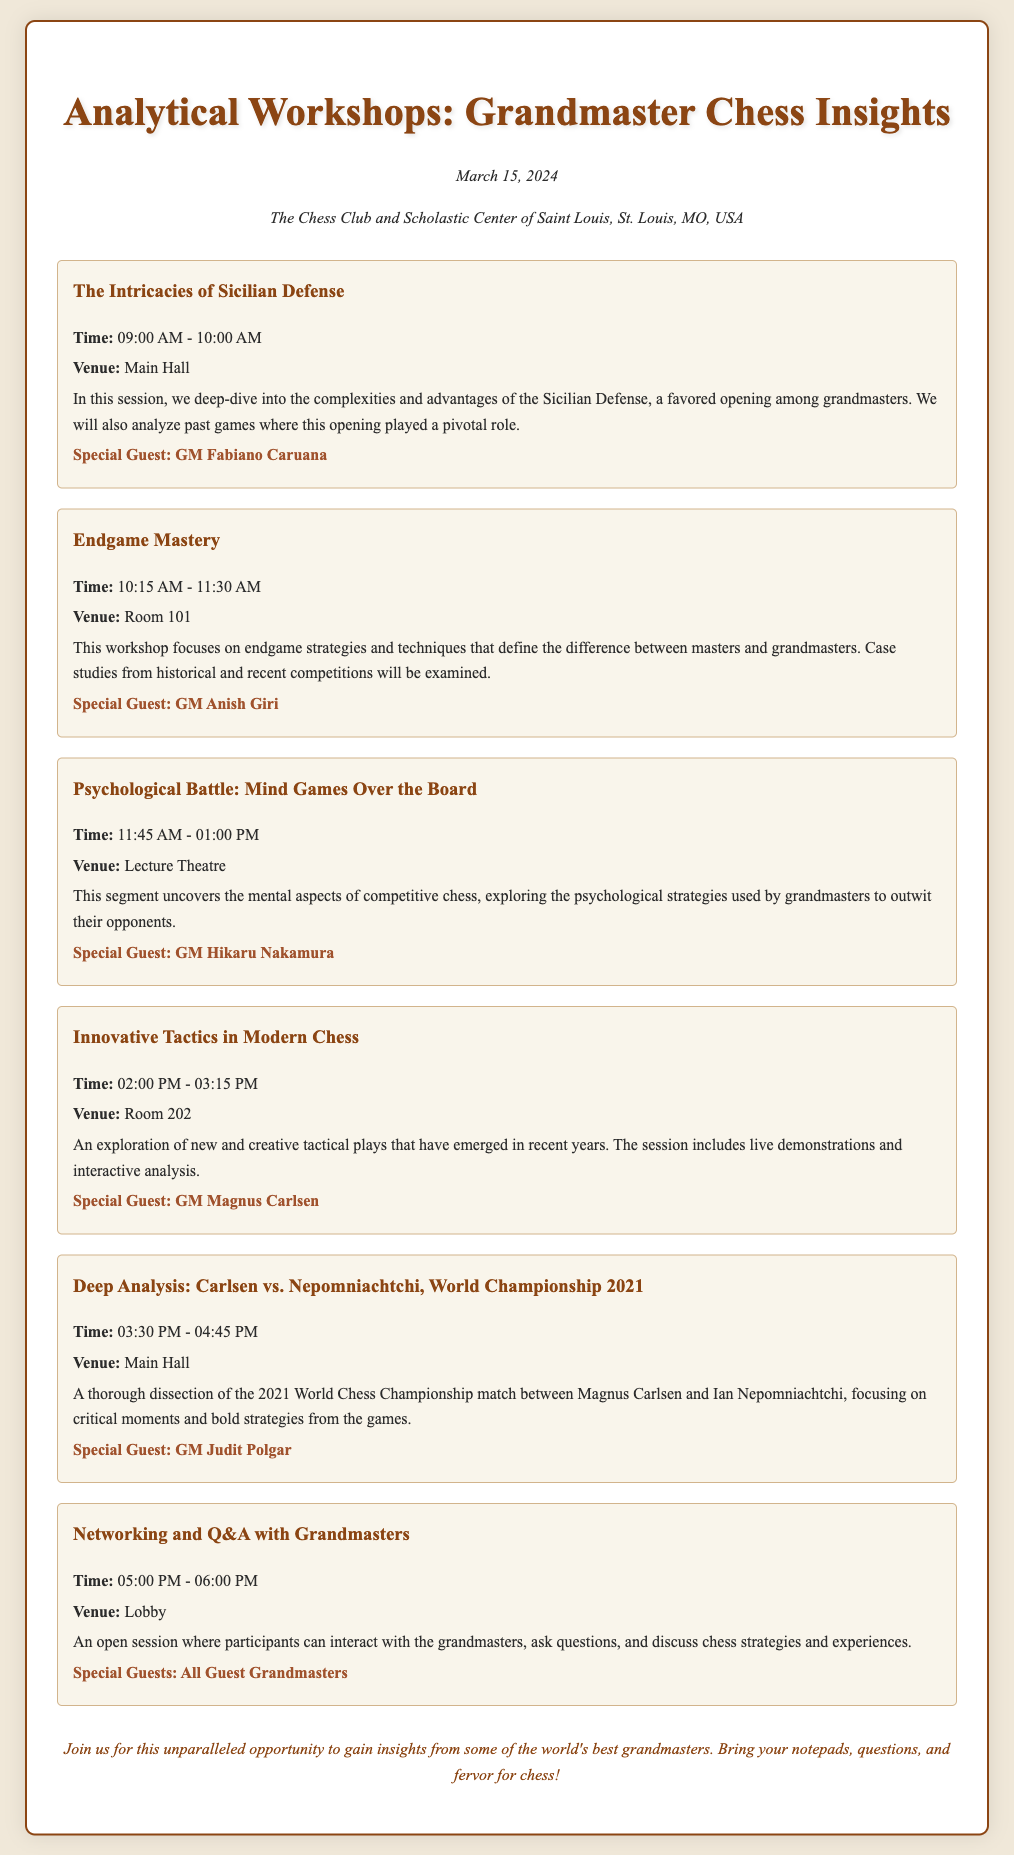What is the date of the event? The date of the event is mentioned in the document as March 15, 2024.
Answer: March 15, 2024 Where is the venue for the workshops? The venue for the workshops is specified as The Chess Club and Scholastic Center of Saint Louis, St. Louis, MO, USA.
Answer: The Chess Club and Scholastic Center of Saint Louis, St. Louis, MO, USA Who is the special guest for the session on Innovative Tactics? The special guest for that session is listed as GM Magnus Carlsen.
Answer: GM Magnus Carlsen What time does the Endgame Mastery workshop start? The start time for the Endgame Mastery workshop is given as 10:15 AM.
Answer: 10:15 AM How many sessions are scheduled before the Networking and Q&A? The document lists a total of five sessions scheduled before the Networking and Q&A session.
Answer: Five What psychological aspect is covered in the workshop segment? The document notes that the segment covers the mental aspects of competitive chess.
Answer: Mental aspects Which grandmaster is noted for the session on Deep Analysis? The grandmaster associated with the Deep Analysis session is GM Judit Polgar.
Answer: GM Judit Polgar In which venue will the Psychological Battle session take place? The venue for the Psychological Battle session is indicated as the Lecture Theatre.
Answer: Lecture Theatre How long is the Networking and Q&A session? The document specifies that the Networking and Q&A session lasts one hour.
Answer: One hour 